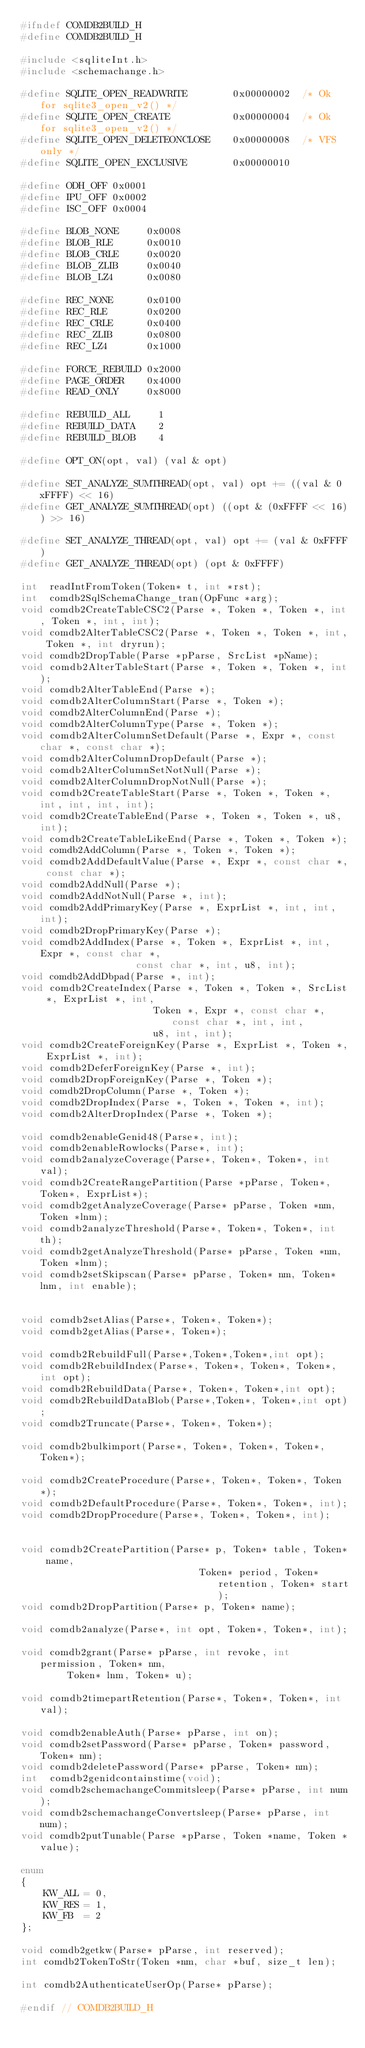<code> <loc_0><loc_0><loc_500><loc_500><_C_>#ifndef COMDB2BUILD_H
#define COMDB2BUILD_H

#include <sqliteInt.h>
#include <schemachange.h>

#define SQLITE_OPEN_READWRITE        0x00000002  /* Ok for sqlite3_open_v2() */
#define SQLITE_OPEN_CREATE           0x00000004  /* Ok for sqlite3_open_v2() */
#define SQLITE_OPEN_DELETEONCLOSE    0x00000008  /* VFS only */
#define SQLITE_OPEN_EXCLUSIVE        0x00000010

#define ODH_OFF 0x0001
#define IPU_OFF 0x0002
#define ISC_OFF 0x0004

#define BLOB_NONE     0x0008
#define BLOB_RLE      0x0010
#define BLOB_CRLE     0x0020
#define BLOB_ZLIB     0x0040
#define BLOB_LZ4      0x0080

#define REC_NONE      0x0100
#define REC_RLE       0x0200
#define REC_CRLE      0x0400
#define REC_ZLIB      0x0800
#define REC_LZ4       0x1000

#define FORCE_REBUILD 0x2000
#define PAGE_ORDER    0x4000
#define READ_ONLY     0x8000

#define REBUILD_ALL     1
#define REBUILD_DATA    2
#define REBUILD_BLOB    4

#define OPT_ON(opt, val) (val & opt)

#define SET_ANALYZE_SUMTHREAD(opt, val) opt += ((val & 0xFFFF) << 16)
#define GET_ANALYZE_SUMTHREAD(opt) ((opt & (0xFFFF << 16)) >> 16)

#define SET_ANALYZE_THREAD(opt, val) opt += (val & 0xFFFF)
#define GET_ANALYZE_THREAD(opt) (opt & 0xFFFF)

int  readIntFromToken(Token* t, int *rst);
int  comdb2SqlSchemaChange_tran(OpFunc *arg);
void comdb2CreateTableCSC2(Parse *, Token *, Token *, int, Token *, int, int);
void comdb2AlterTableCSC2(Parse *, Token *, Token *, int, Token *, int dryrun);
void comdb2DropTable(Parse *pParse, SrcList *pName);
void comdb2AlterTableStart(Parse *, Token *, Token *, int);
void comdb2AlterTableEnd(Parse *);
void comdb2AlterColumnStart(Parse *, Token *);
void comdb2AlterColumnEnd(Parse *);
void comdb2AlterColumnType(Parse *, Token *);
void comdb2AlterColumnSetDefault(Parse *, Expr *, const char *, const char *);
void comdb2AlterColumnDropDefault(Parse *);
void comdb2AlterColumnSetNotNull(Parse *);
void comdb2AlterColumnDropNotNull(Parse *);
void comdb2CreateTableStart(Parse *, Token *, Token *, int, int, int, int);
void comdb2CreateTableEnd(Parse *, Token *, Token *, u8, int);
void comdb2CreateTableLikeEnd(Parse *, Token *, Token *);
void comdb2AddColumn(Parse *, Token *, Token *);
void comdb2AddDefaultValue(Parse *, Expr *, const char *, const char *);
void comdb2AddNull(Parse *);
void comdb2AddNotNull(Parse *, int);
void comdb2AddPrimaryKey(Parse *, ExprList *, int, int, int);
void comdb2DropPrimaryKey(Parse *);
void comdb2AddIndex(Parse *, Token *, ExprList *, int, Expr *, const char *,
                    const char *, int, u8, int);
void comdb2AddDbpad(Parse *, int);
void comdb2CreateIndex(Parse *, Token *, Token *, SrcList *, ExprList *, int,
                       Token *, Expr *, const char *, const char *, int, int,
                       u8, int, int);
void comdb2CreateForeignKey(Parse *, ExprList *, Token *, ExprList *, int);
void comdb2DeferForeignKey(Parse *, int);
void comdb2DropForeignKey(Parse *, Token *);
void comdb2DropColumn(Parse *, Token *);
void comdb2DropIndex(Parse *, Token *, Token *, int);
void comdb2AlterDropIndex(Parse *, Token *);

void comdb2enableGenid48(Parse*, int);
void comdb2enableRowlocks(Parse*, int);
void comdb2analyzeCoverage(Parse*, Token*, Token*, int val);
void comdb2CreateRangePartition(Parse *pParse, Token*, Token*, ExprList*);
void comdb2getAnalyzeCoverage(Parse* pParse, Token *nm, Token *lnm);
void comdb2analyzeThreshold(Parse*, Token*, Token*, int th);
void comdb2getAnalyzeThreshold(Parse* pParse, Token *nm, Token *lnm);
void comdb2setSkipscan(Parse* pParse, Token* nm, Token* lnm, int enable);


void comdb2setAlias(Parse*, Token*, Token*);
void comdb2getAlias(Parse*, Token*);

void comdb2RebuildFull(Parse*,Token*,Token*,int opt);
void comdb2RebuildIndex(Parse*, Token*, Token*, Token*,int opt);
void comdb2RebuildData(Parse*, Token*, Token*,int opt);
void comdb2RebuildDataBlob(Parse*,Token*, Token*,int opt);
void comdb2Truncate(Parse*, Token*, Token*);

void comdb2bulkimport(Parse*, Token*, Token*, Token*, Token*);

void comdb2CreateProcedure(Parse*, Token*, Token*, Token*);
void comdb2DefaultProcedure(Parse*, Token*, Token*, int);
void comdb2DropProcedure(Parse*, Token*, Token*, int);


void comdb2CreatePartition(Parse* p, Token* table, Token* name, 
                               Token* period, Token* retention, Token* start);
void comdb2DropPartition(Parse* p, Token* name);

void comdb2analyze(Parse*, int opt, Token*, Token*, int);

void comdb2grant(Parse* pParse, int revoke, int permission, Token* nm,
        Token* lnm, Token* u);

void comdb2timepartRetention(Parse*, Token*, Token*, int val);

void comdb2enableAuth(Parse* pParse, int on);
void comdb2setPassword(Parse* pParse, Token* password, Token* nm);
void comdb2deletePassword(Parse* pParse, Token* nm);
int  comdb2genidcontainstime(void);
void comdb2schemachangeCommitsleep(Parse* pParse, int num);
void comdb2schemachangeConvertsleep(Parse* pParse, int num);
void comdb2putTunable(Parse *pParse, Token *name, Token *value);

enum
{
    KW_ALL = 0,
    KW_RES = 1,
    KW_FB  = 2
};

void comdb2getkw(Parse* pParse, int reserved);
int comdb2TokenToStr(Token *nm, char *buf, size_t len);

int comdb2AuthenticateUserOp(Parse* pParse);

#endif // COMDB2BUILD_H
</code> 